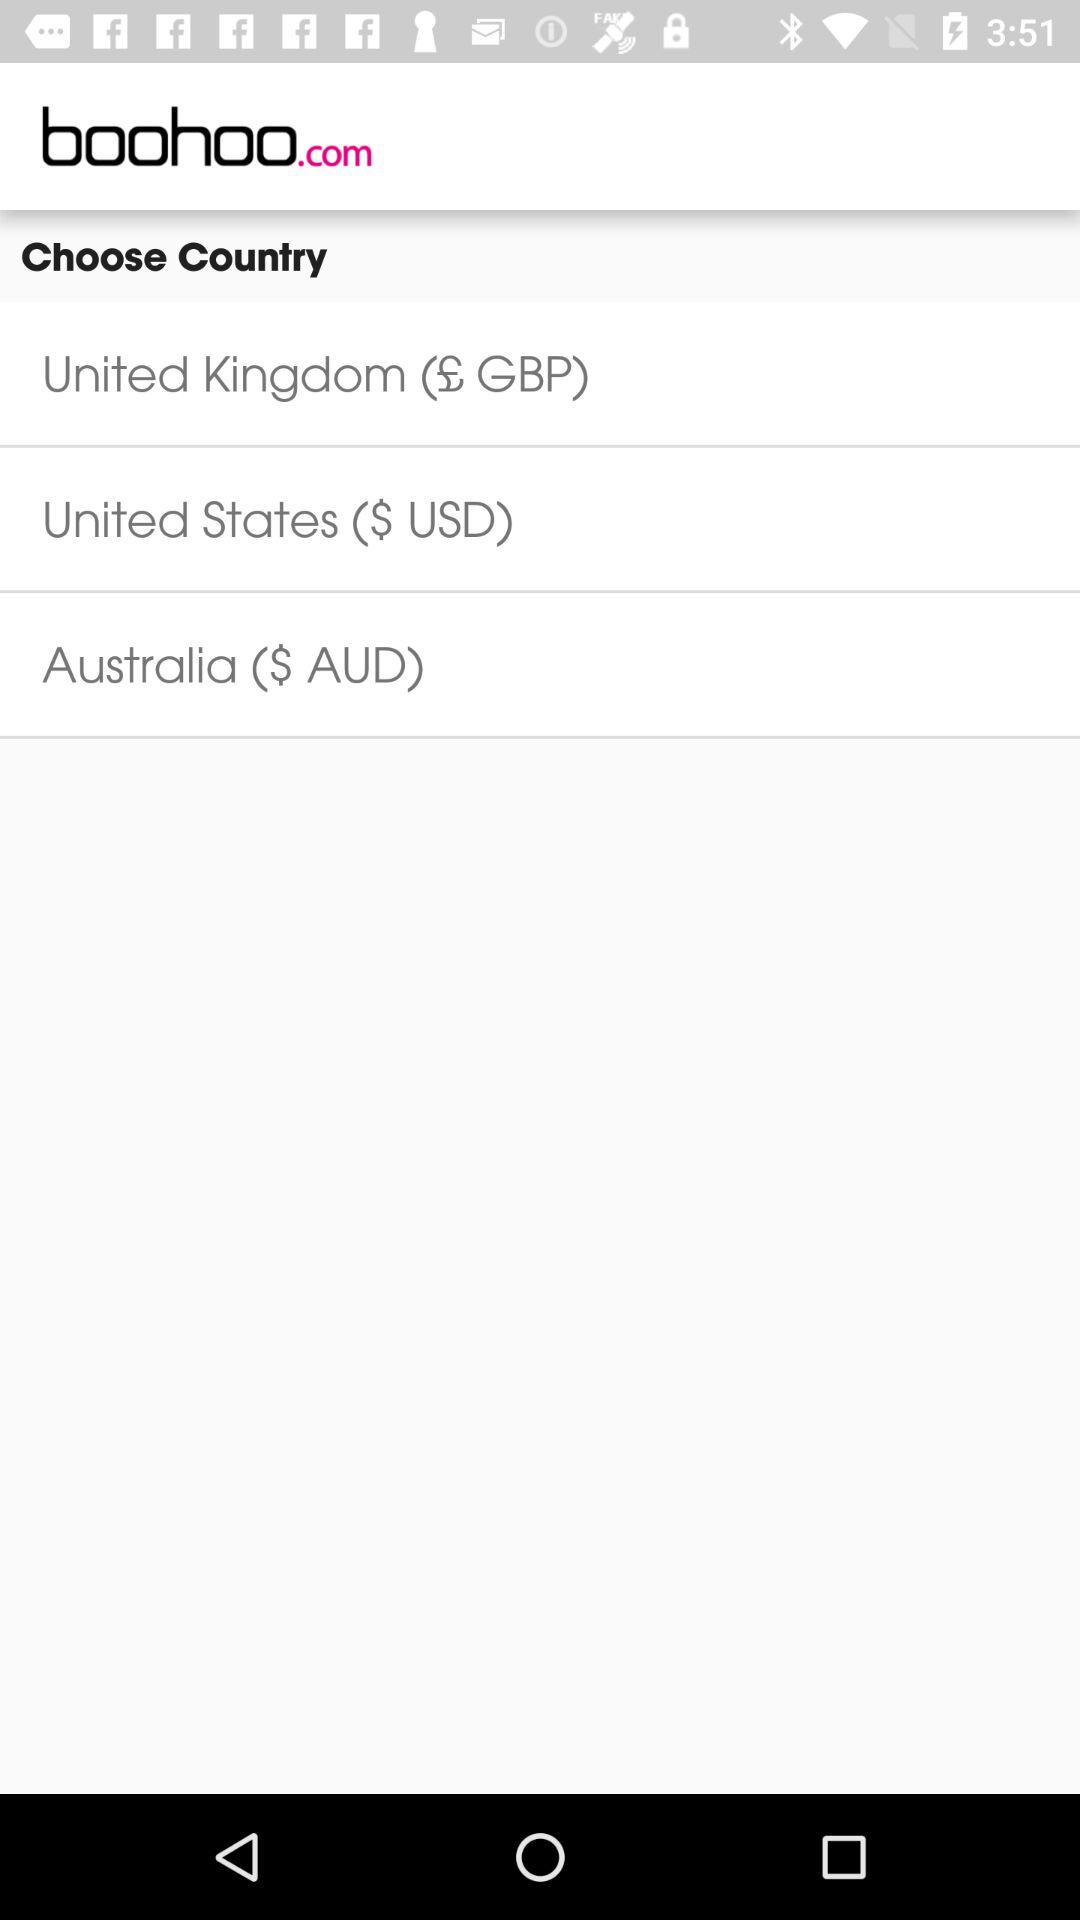What is the United States' monetary unit? The United States' monetary unit is USD. 